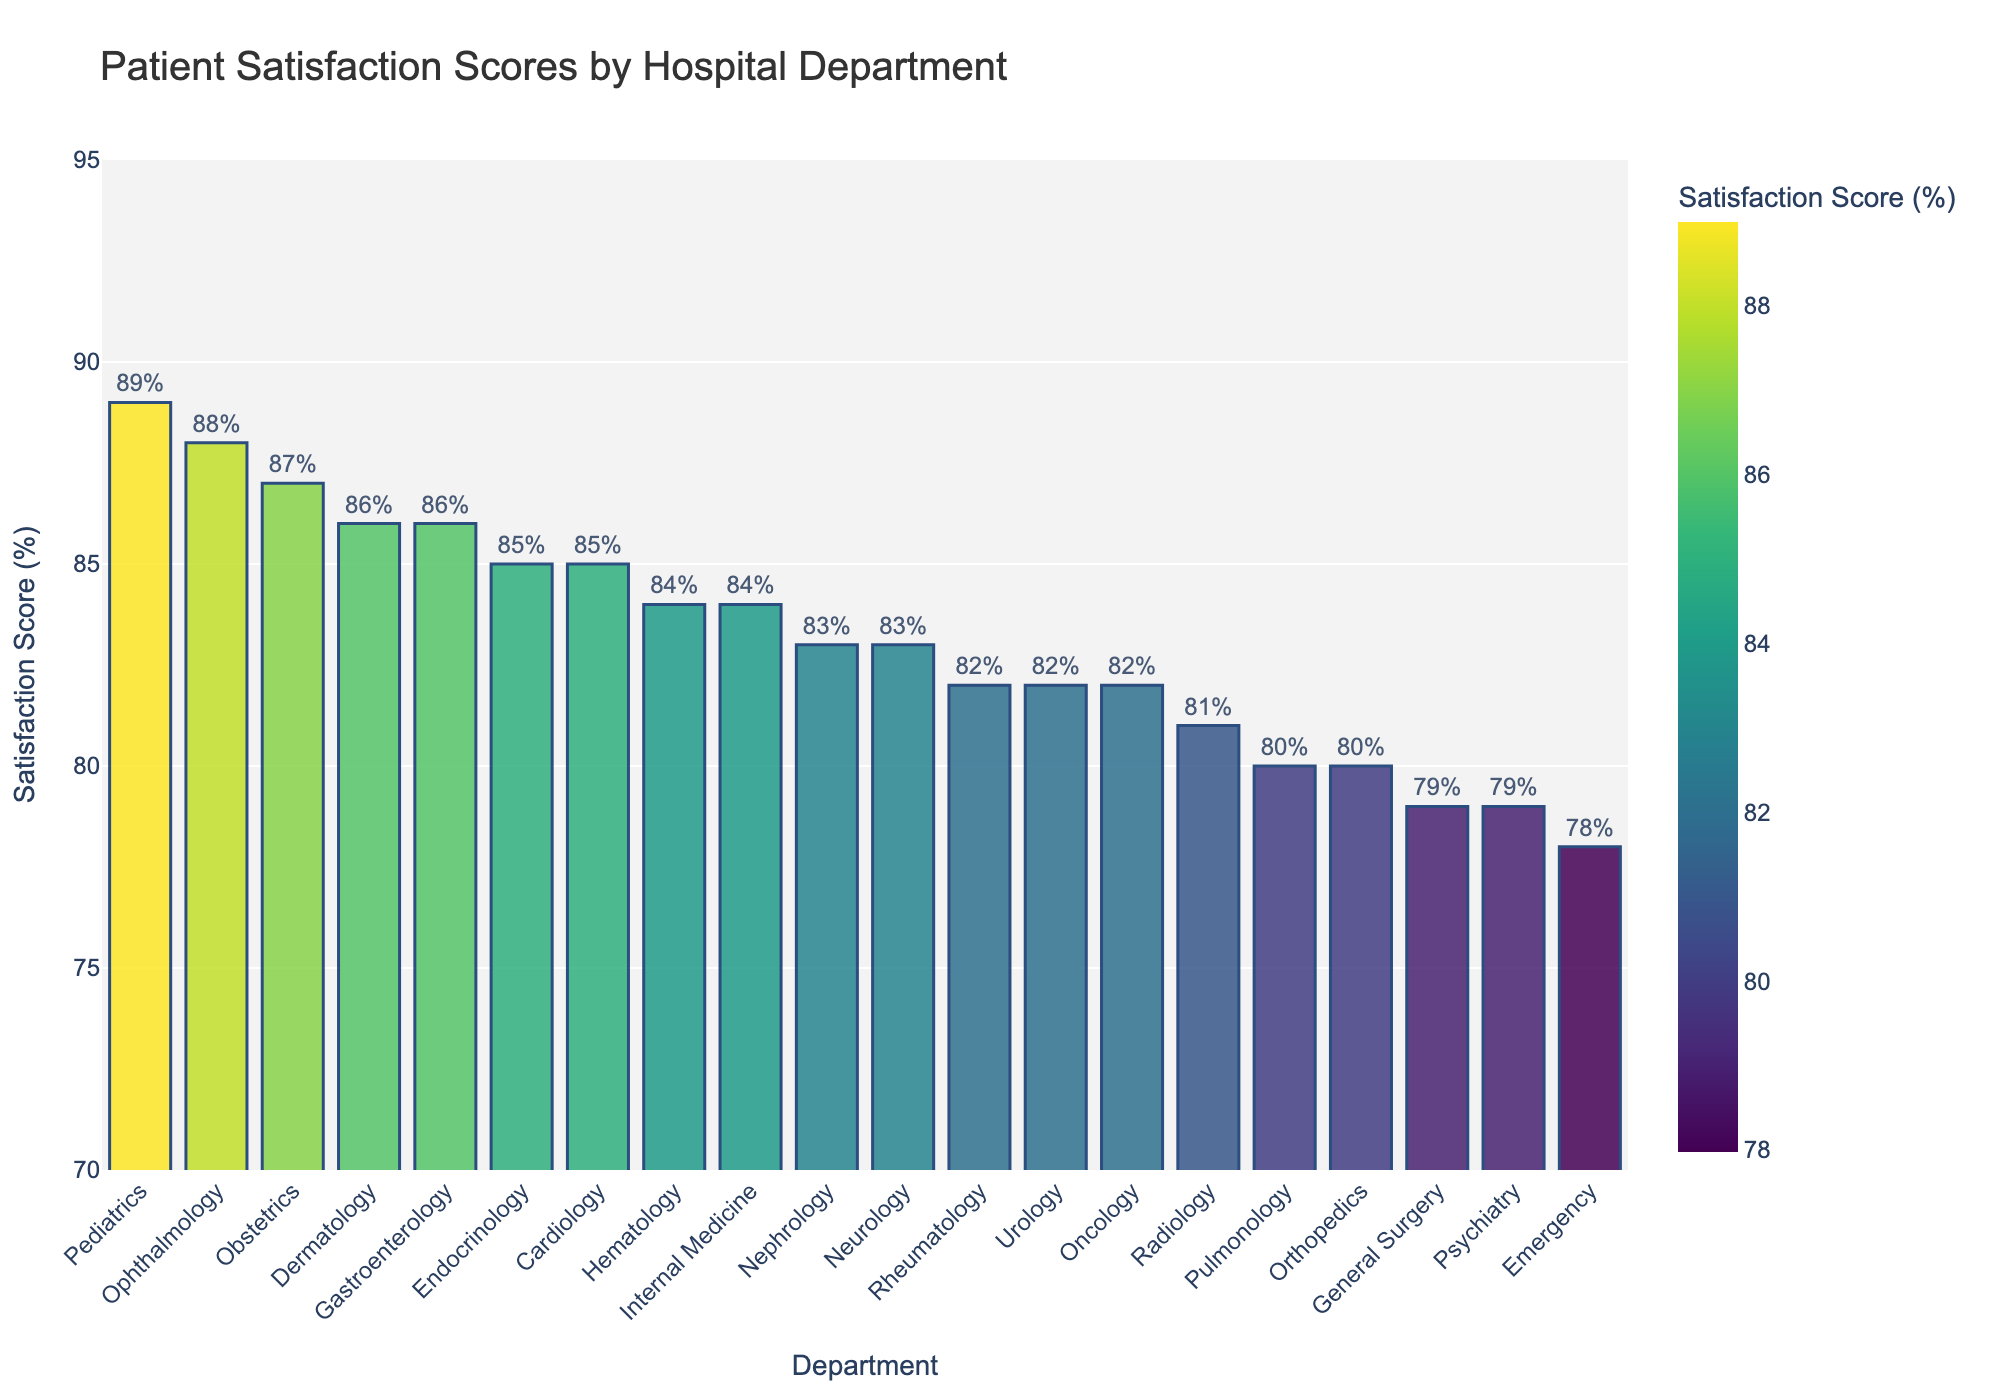Which department has the highest patient satisfaction score? By examining the heights of the bars, Pediatrics has the highest satisfaction score with a score of 89.
Answer: Pediatrics Which department has the lowest patient satisfaction score? By looking at the shortest bar, Emergency has the lowest satisfaction score with a score of 78.
Answer: Emergency What is the difference in satisfaction scores between Obstetrics and Orthopedics? Obstetrics has a satisfaction score of 87, and Orthopedics has 80. The difference is 87 - 80 = 7.
Answer: 7 Which department has a higher satisfaction score, Neurology or Nephrology? Neurology has a score of 83 and Nephrology also has a score of 83. Both departments have the same satisfaction score.
Answer: Same If we group the departments into categories of scores above 85 and below 85, how many departments fall into each category? Departments above 85 are Pediatrics, Obstetrics, Gastroenterology, Ophthalmology, and Dermatology. Those below 85 are Emergency, Cardiology, Oncology, Orthopedics, Neurology, General Surgery, Radiology, Internal Medicine, Urology, Pulmonology, Psychiatry, Rheumatology, and Hematology. So, 5 departments score above 85 and 15 below 85.
Answer: 5 above 85; 15 below 85 What is the average satisfaction score of Oncology, Pediatrics, and Psychiatry? Oncology has a score of 82, Pediatrics is 89, and Psychiatry is 79. The average is (82 + 89 + 79) / 3 = 250 / 3 ≈ 83.33.
Answer: 83.33 How many departments have satisfaction scores greater than 80 but less than or equal to 85? The departments with scores in this range are Cardiology (85), Internal Medicine (84), Endocrinology (85), Neurology (83), Nephrology (83), Oncology (82), Urology (82), Radiology (81), Pulmonology (80), Rheumatology (82). Counting these departments equals 10.
Answer: 10 Which department's bar is visually the second highest in the plot? By looking at the bar heights, Ophthalmology with a satisfaction score of 88 is the second highest.
Answer: Ophthalmology What is the sum of satisfaction scores for General Surgery and Dermatology? General Surgery has a score of 79 and Dermatology has 86. The sum is 79 + 86 = 165.
Answer: 165 What is the median satisfaction score of the departments displayed in the figure? To find the median, list the satisfaction scores in ascending order: 78, 79, 79, 80, 80, 81, 82, 82, 82, 83, 83, 84, 84, 85, 85, 86, 86, 87, 88, 89. There are 20 departments, so the median is the average of the 10th and 11th values: (83 + 83) / 2 = 83.
Answer: 83 